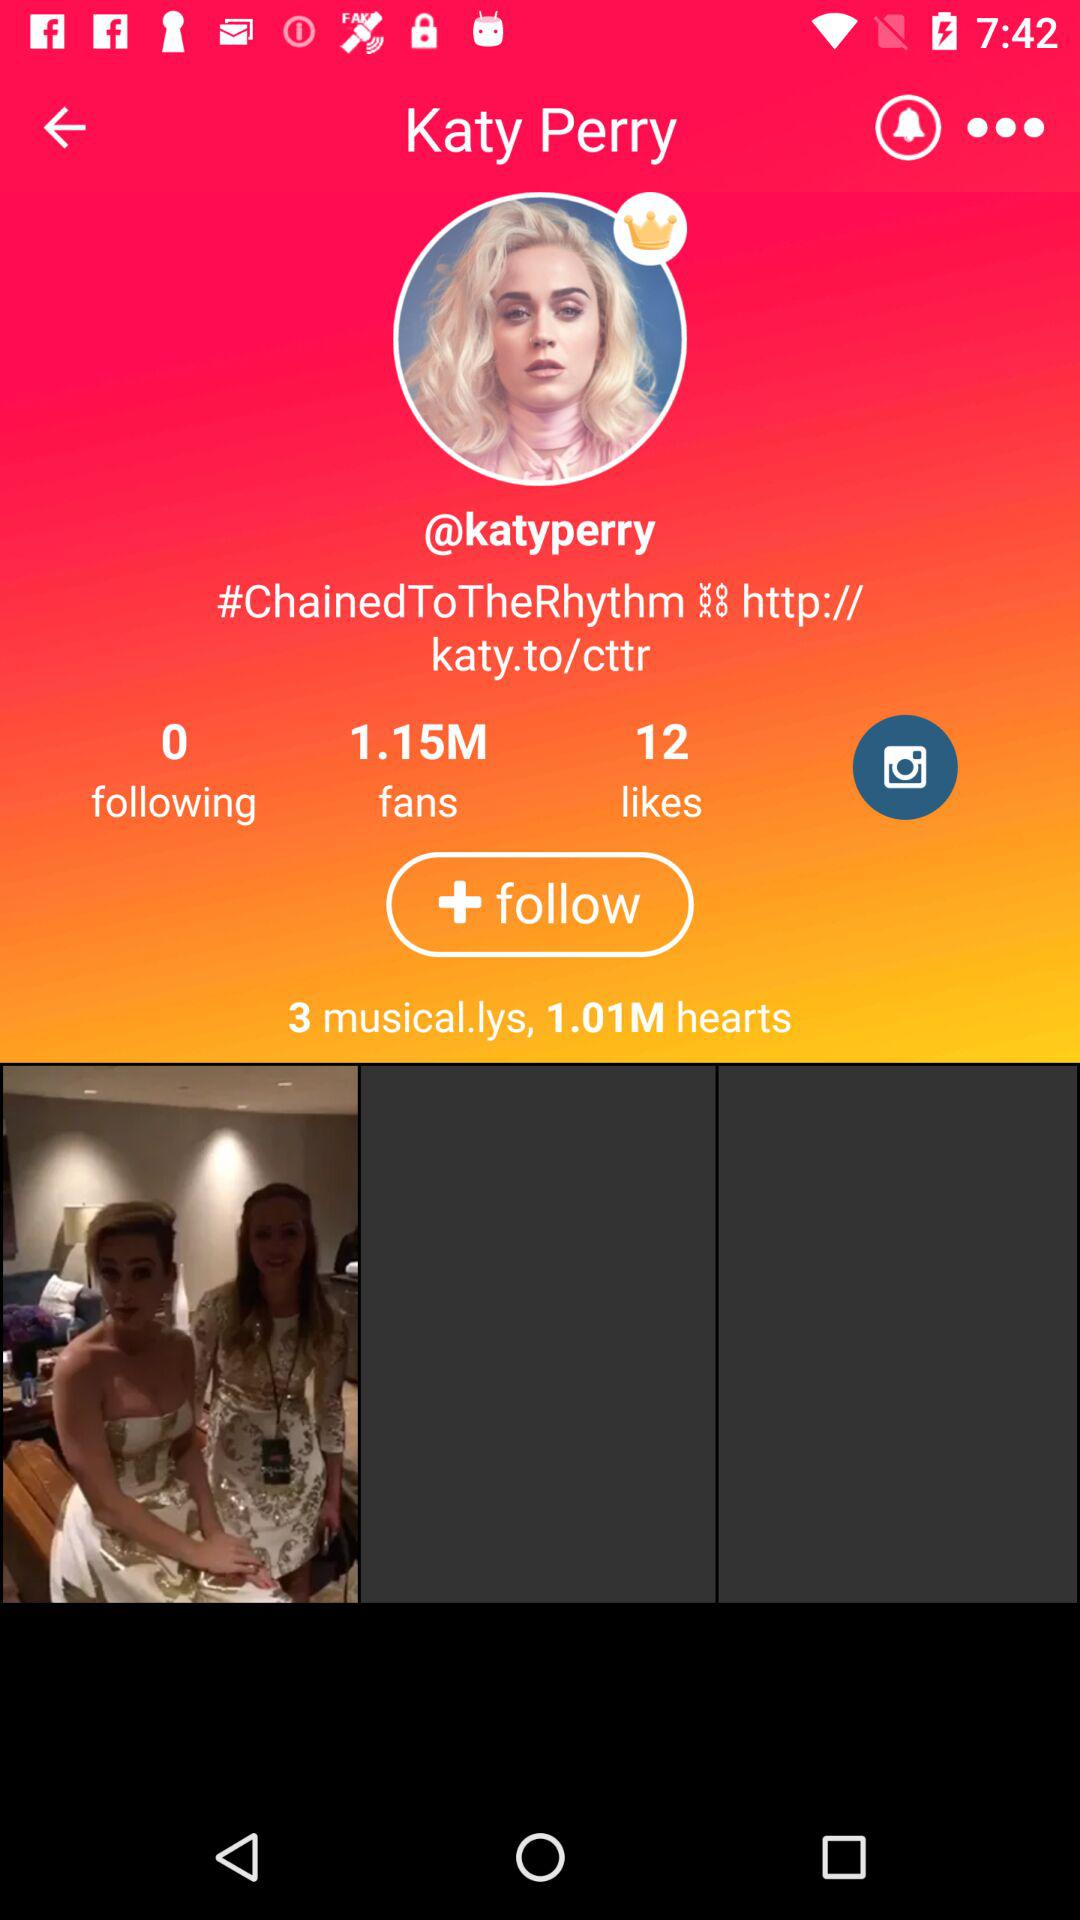How many fans does Katy Perry have? Katy Perry has 1.15 million fans. 